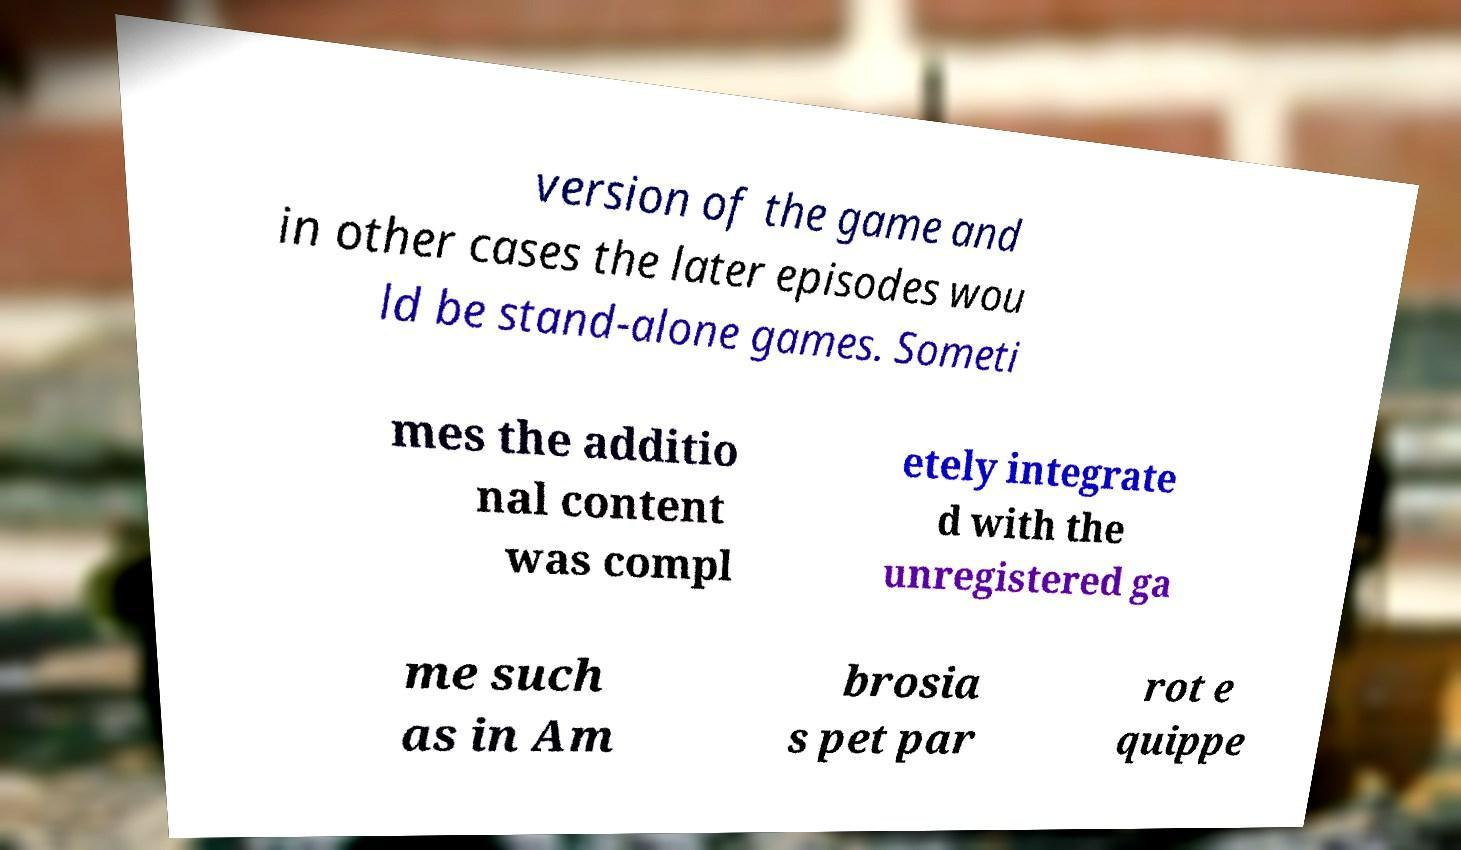I need the written content from this picture converted into text. Can you do that? version of the game and in other cases the later episodes wou ld be stand-alone games. Someti mes the additio nal content was compl etely integrate d with the unregistered ga me such as in Am brosia s pet par rot e quippe 